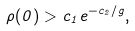<formula> <loc_0><loc_0><loc_500><loc_500>\rho ( 0 ) > c _ { 1 } e ^ { - c _ { 2 } / g } ,</formula> 